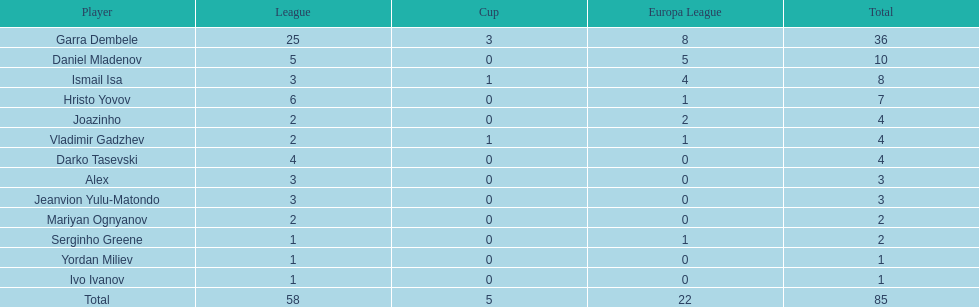What is the disparity between vladimir gadzhev and yordan miliev's tallies? 3. 